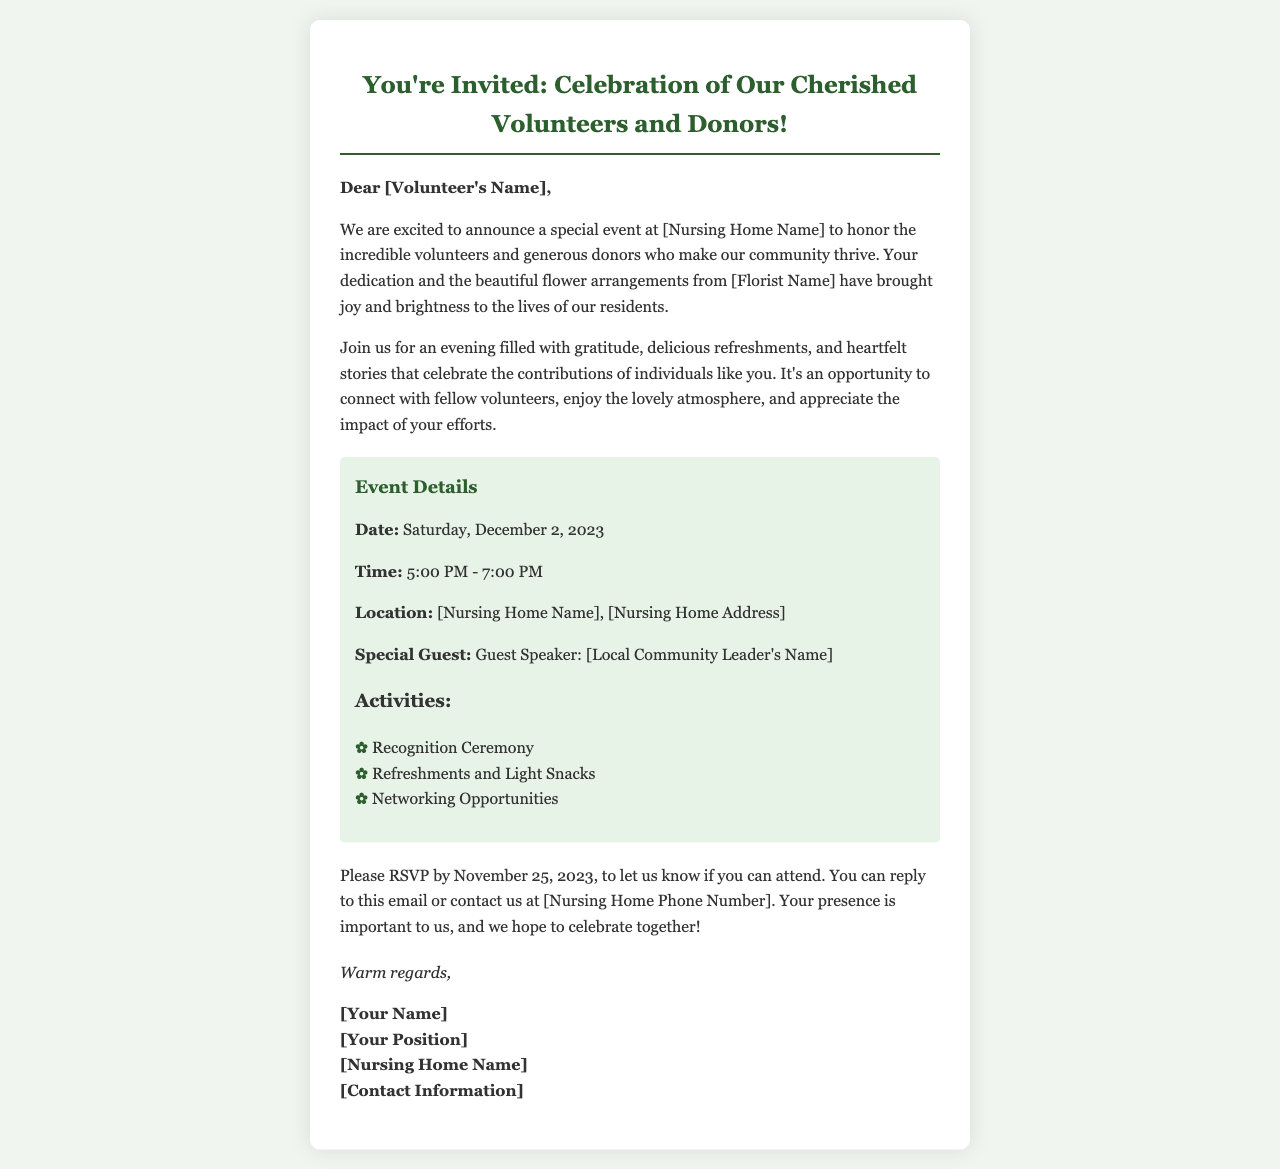What is the date of the event? The event is scheduled for Saturday, December 2, 2023.
Answer: Saturday, December 2, 2023 What time does the celebration start? The celebration begins at 5:00 PM.
Answer: 5:00 PM Who is the special guest speaker? The document mentions a local community leader but does not provide a specific name.
Answer: [Local Community Leader's Name] What type of refreshments will be served? The document indicates that there will be light snacks and refreshments.
Answer: Refreshments and Light Snacks By when should I RSVP? The RSVP deadline provided in the document is November 25, 2023.
Answer: November 25, 2023 What is the main purpose of the event? The purpose is to honor volunteers and donors who support the nursing home.
Answer: Honor volunteers and donors How can I RSVP for the event? The document states that you can reply to the email or contact the nursing home by phone.
Answer: Reply to this email or contact [Nursing Home Phone Number] What is the atmosphere expected to be like at the event? The document describes the atmosphere as lovely and one for connection and appreciation.
Answer: Lovely atmosphere What activities are planned for the event? The activities include a recognition ceremony, refreshments, and networking opportunities.
Answer: Recognition Ceremony, Refreshments and Light Snacks, Networking Opportunities 